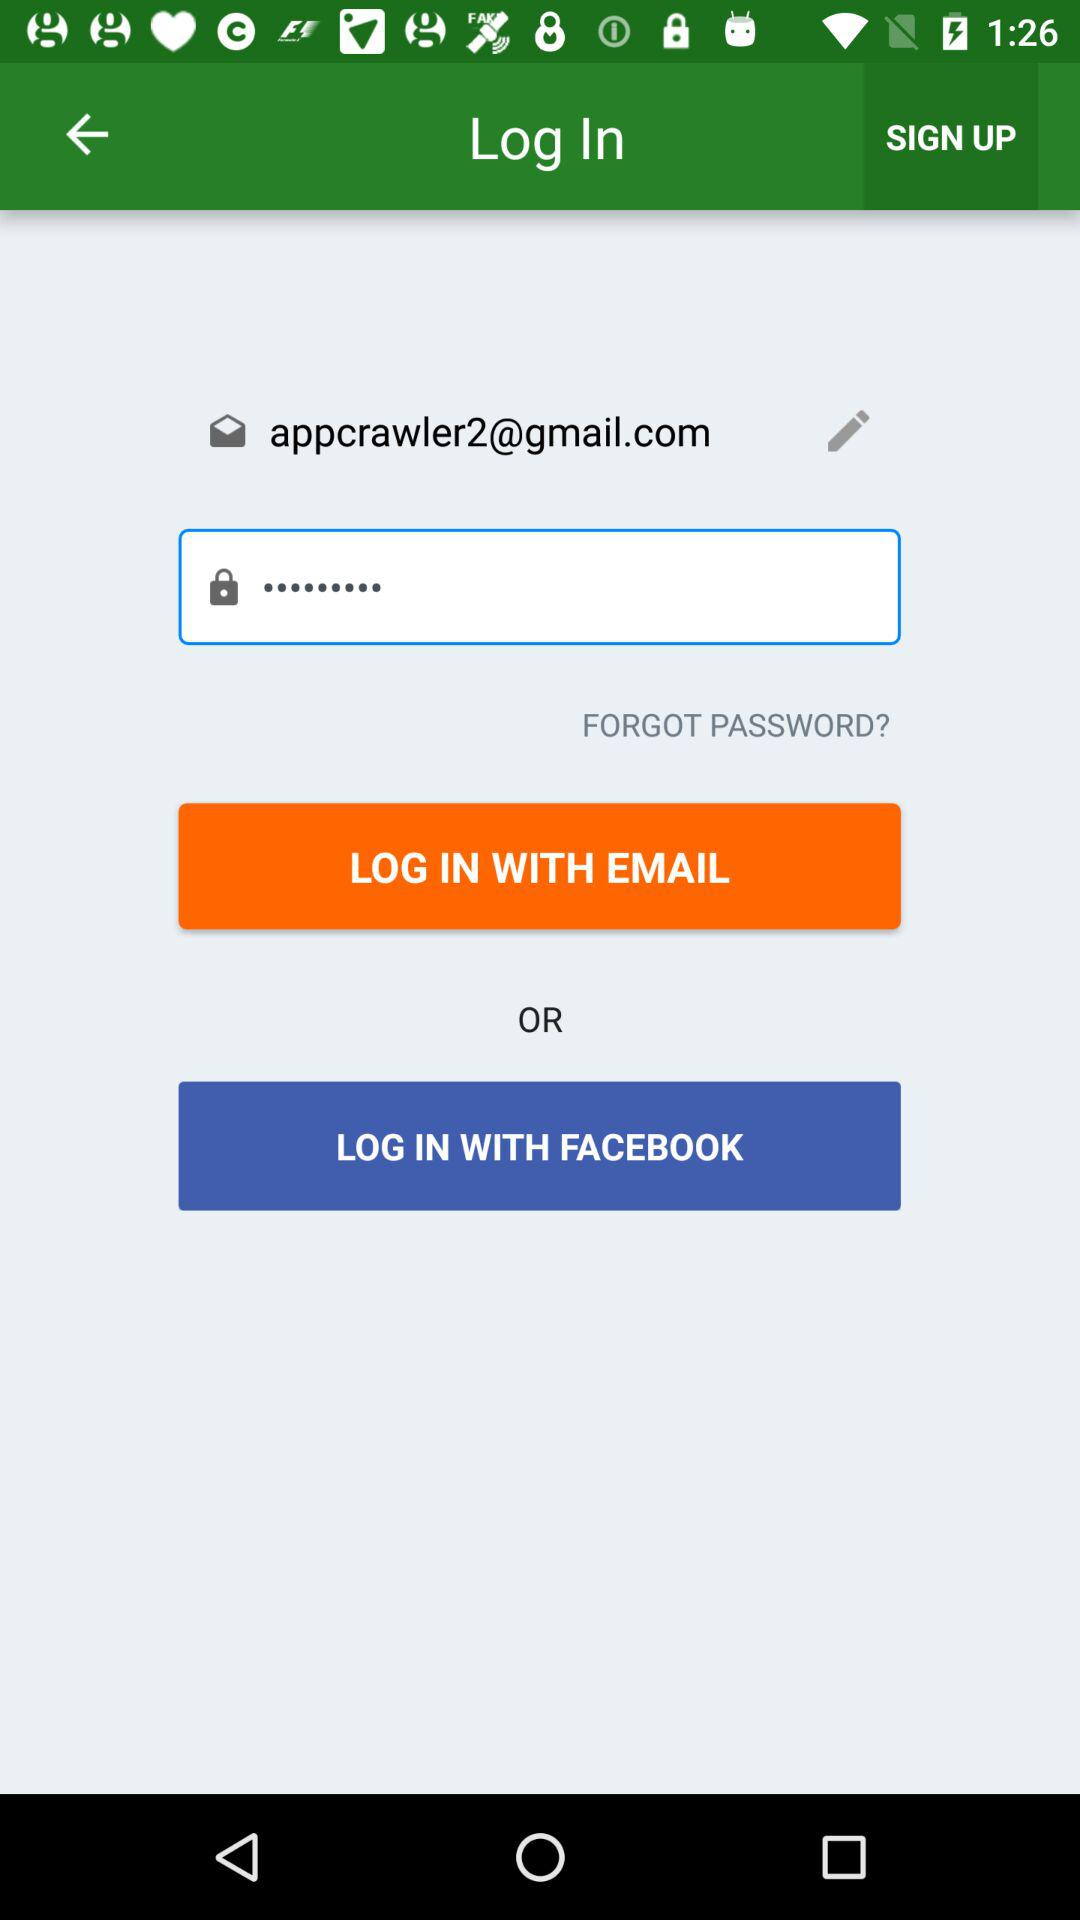What is the given email address? The given email address is appcrawler2@gmail.com. 